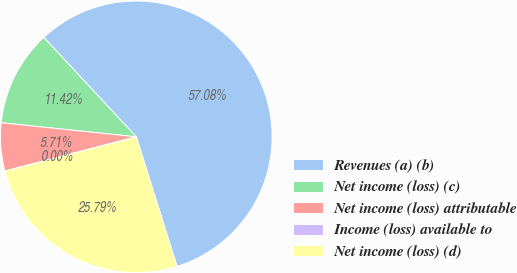Convert chart to OTSL. <chart><loc_0><loc_0><loc_500><loc_500><pie_chart><fcel>Revenues (a) (b)<fcel>Net income (loss) (c)<fcel>Net income (loss) attributable<fcel>Income (loss) available to<fcel>Net income (loss) (d)<nl><fcel>57.08%<fcel>11.42%<fcel>5.71%<fcel>0.0%<fcel>25.79%<nl></chart> 